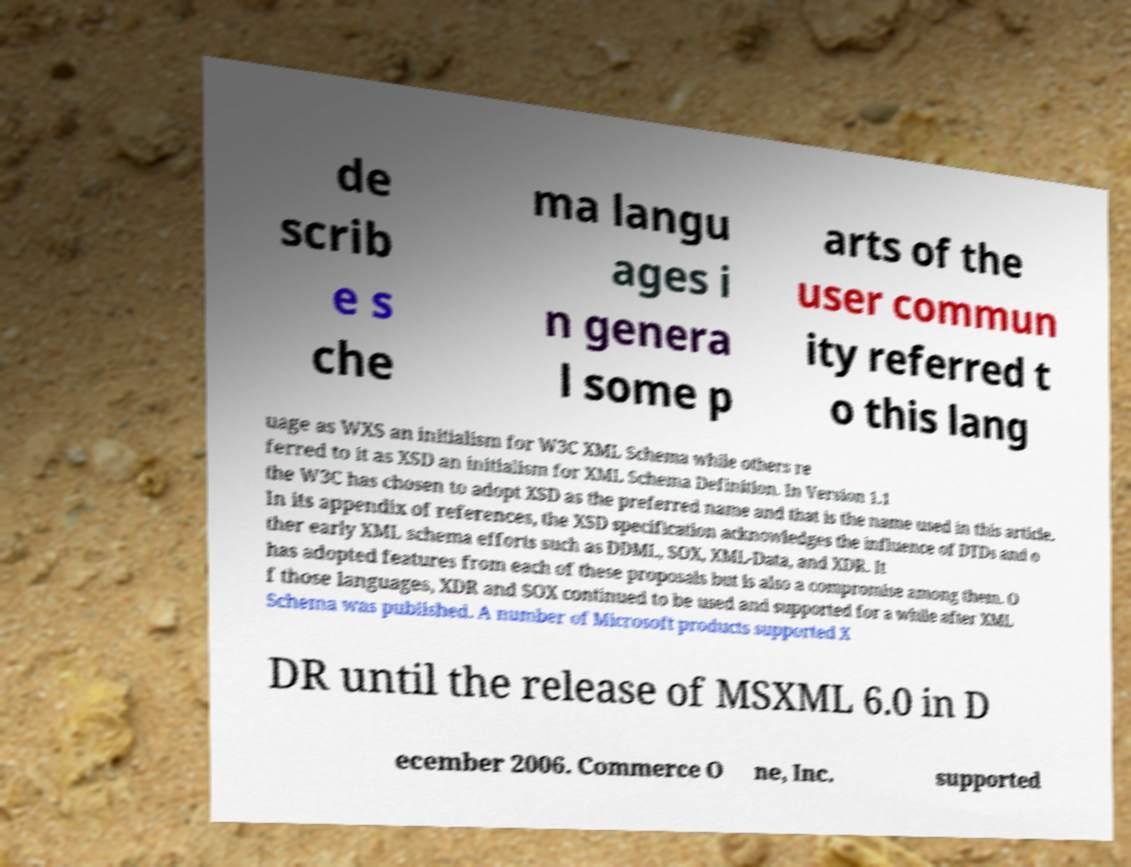There's text embedded in this image that I need extracted. Can you transcribe it verbatim? de scrib e s che ma langu ages i n genera l some p arts of the user commun ity referred t o this lang uage as WXS an initialism for W3C XML Schema while others re ferred to it as XSD an initialism for XML Schema Definition. In Version 1.1 the W3C has chosen to adopt XSD as the preferred name and that is the name used in this article. In its appendix of references, the XSD specification acknowledges the influence of DTDs and o ther early XML schema efforts such as DDML, SOX, XML-Data, and XDR. It has adopted features from each of these proposals but is also a compromise among them. O f those languages, XDR and SOX continued to be used and supported for a while after XML Schema was published. A number of Microsoft products supported X DR until the release of MSXML 6.0 in D ecember 2006. Commerce O ne, Inc. supported 